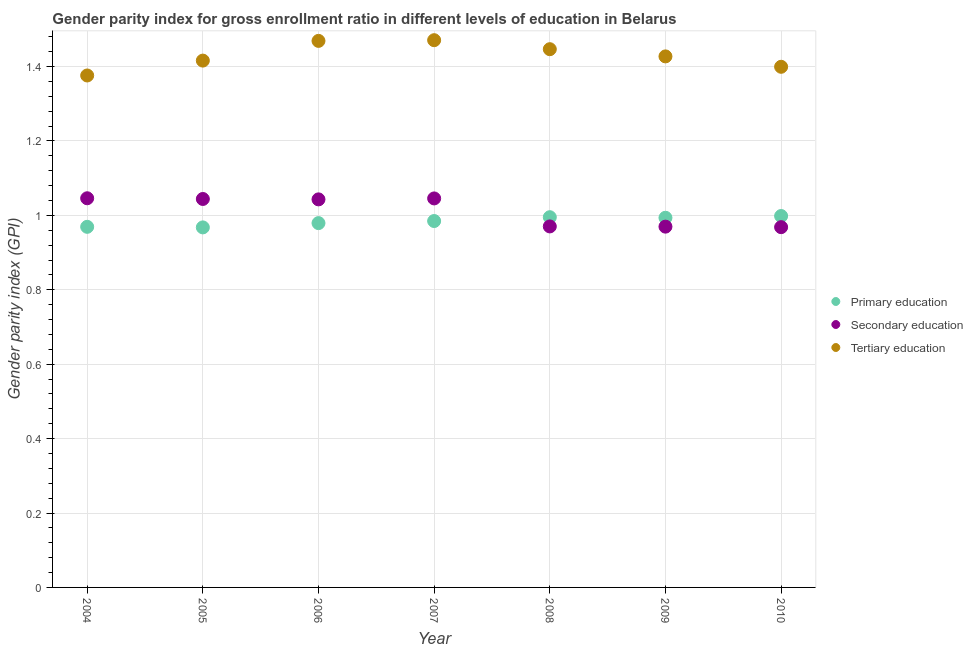How many different coloured dotlines are there?
Offer a very short reply. 3. Is the number of dotlines equal to the number of legend labels?
Provide a succinct answer. Yes. What is the gender parity index in tertiary education in 2004?
Your response must be concise. 1.38. Across all years, what is the maximum gender parity index in primary education?
Your answer should be very brief. 1. Across all years, what is the minimum gender parity index in primary education?
Your answer should be very brief. 0.97. What is the total gender parity index in primary education in the graph?
Your answer should be very brief. 6.89. What is the difference between the gender parity index in secondary education in 2009 and that in 2010?
Your response must be concise. 0. What is the difference between the gender parity index in secondary education in 2010 and the gender parity index in primary education in 2006?
Ensure brevity in your answer.  -0.01. What is the average gender parity index in primary education per year?
Offer a very short reply. 0.98. In the year 2008, what is the difference between the gender parity index in secondary education and gender parity index in primary education?
Provide a succinct answer. -0.02. What is the ratio of the gender parity index in secondary education in 2004 to that in 2009?
Your answer should be very brief. 1.08. What is the difference between the highest and the second highest gender parity index in tertiary education?
Your answer should be very brief. 0. What is the difference between the highest and the lowest gender parity index in primary education?
Your response must be concise. 0.03. Is the gender parity index in secondary education strictly greater than the gender parity index in primary education over the years?
Provide a short and direct response. No. How many years are there in the graph?
Provide a succinct answer. 7. What is the difference between two consecutive major ticks on the Y-axis?
Give a very brief answer. 0.2. Are the values on the major ticks of Y-axis written in scientific E-notation?
Your answer should be compact. No. Does the graph contain grids?
Your answer should be very brief. Yes. Where does the legend appear in the graph?
Keep it short and to the point. Center right. What is the title of the graph?
Ensure brevity in your answer.  Gender parity index for gross enrollment ratio in different levels of education in Belarus. Does "Labor Tax" appear as one of the legend labels in the graph?
Your answer should be compact. No. What is the label or title of the X-axis?
Ensure brevity in your answer.  Year. What is the label or title of the Y-axis?
Offer a very short reply. Gender parity index (GPI). What is the Gender parity index (GPI) in Primary education in 2004?
Your answer should be compact. 0.97. What is the Gender parity index (GPI) of Secondary education in 2004?
Keep it short and to the point. 1.05. What is the Gender parity index (GPI) of Tertiary education in 2004?
Your answer should be compact. 1.38. What is the Gender parity index (GPI) in Primary education in 2005?
Provide a succinct answer. 0.97. What is the Gender parity index (GPI) of Secondary education in 2005?
Keep it short and to the point. 1.04. What is the Gender parity index (GPI) in Tertiary education in 2005?
Your answer should be very brief. 1.42. What is the Gender parity index (GPI) in Primary education in 2006?
Provide a succinct answer. 0.98. What is the Gender parity index (GPI) in Secondary education in 2006?
Give a very brief answer. 1.04. What is the Gender parity index (GPI) in Tertiary education in 2006?
Your response must be concise. 1.47. What is the Gender parity index (GPI) of Primary education in 2007?
Your answer should be very brief. 0.98. What is the Gender parity index (GPI) of Secondary education in 2007?
Offer a terse response. 1.05. What is the Gender parity index (GPI) in Tertiary education in 2007?
Provide a short and direct response. 1.47. What is the Gender parity index (GPI) in Primary education in 2008?
Offer a very short reply. 1. What is the Gender parity index (GPI) in Secondary education in 2008?
Keep it short and to the point. 0.97. What is the Gender parity index (GPI) in Tertiary education in 2008?
Provide a succinct answer. 1.45. What is the Gender parity index (GPI) of Primary education in 2009?
Keep it short and to the point. 0.99. What is the Gender parity index (GPI) of Secondary education in 2009?
Ensure brevity in your answer.  0.97. What is the Gender parity index (GPI) of Tertiary education in 2009?
Give a very brief answer. 1.43. What is the Gender parity index (GPI) of Primary education in 2010?
Your response must be concise. 1. What is the Gender parity index (GPI) of Secondary education in 2010?
Your answer should be very brief. 0.97. What is the Gender parity index (GPI) of Tertiary education in 2010?
Give a very brief answer. 1.4. Across all years, what is the maximum Gender parity index (GPI) of Primary education?
Offer a very short reply. 1. Across all years, what is the maximum Gender parity index (GPI) in Secondary education?
Provide a short and direct response. 1.05. Across all years, what is the maximum Gender parity index (GPI) of Tertiary education?
Your response must be concise. 1.47. Across all years, what is the minimum Gender parity index (GPI) in Primary education?
Your answer should be compact. 0.97. Across all years, what is the minimum Gender parity index (GPI) of Secondary education?
Provide a short and direct response. 0.97. Across all years, what is the minimum Gender parity index (GPI) of Tertiary education?
Offer a terse response. 1.38. What is the total Gender parity index (GPI) in Primary education in the graph?
Offer a terse response. 6.89. What is the total Gender parity index (GPI) of Secondary education in the graph?
Provide a succinct answer. 7.09. What is the total Gender parity index (GPI) in Tertiary education in the graph?
Offer a very short reply. 10.01. What is the difference between the Gender parity index (GPI) of Primary education in 2004 and that in 2005?
Ensure brevity in your answer.  0. What is the difference between the Gender parity index (GPI) of Secondary education in 2004 and that in 2005?
Provide a succinct answer. 0. What is the difference between the Gender parity index (GPI) in Tertiary education in 2004 and that in 2005?
Make the answer very short. -0.04. What is the difference between the Gender parity index (GPI) of Primary education in 2004 and that in 2006?
Provide a succinct answer. -0.01. What is the difference between the Gender parity index (GPI) in Secondary education in 2004 and that in 2006?
Keep it short and to the point. 0. What is the difference between the Gender parity index (GPI) of Tertiary education in 2004 and that in 2006?
Offer a very short reply. -0.09. What is the difference between the Gender parity index (GPI) in Primary education in 2004 and that in 2007?
Offer a terse response. -0.02. What is the difference between the Gender parity index (GPI) in Tertiary education in 2004 and that in 2007?
Your response must be concise. -0.09. What is the difference between the Gender parity index (GPI) in Primary education in 2004 and that in 2008?
Give a very brief answer. -0.03. What is the difference between the Gender parity index (GPI) in Secondary education in 2004 and that in 2008?
Offer a very short reply. 0.08. What is the difference between the Gender parity index (GPI) of Tertiary education in 2004 and that in 2008?
Your answer should be very brief. -0.07. What is the difference between the Gender parity index (GPI) in Primary education in 2004 and that in 2009?
Provide a short and direct response. -0.02. What is the difference between the Gender parity index (GPI) in Secondary education in 2004 and that in 2009?
Offer a very short reply. 0.08. What is the difference between the Gender parity index (GPI) in Tertiary education in 2004 and that in 2009?
Your answer should be very brief. -0.05. What is the difference between the Gender parity index (GPI) of Primary education in 2004 and that in 2010?
Give a very brief answer. -0.03. What is the difference between the Gender parity index (GPI) of Secondary education in 2004 and that in 2010?
Provide a succinct answer. 0.08. What is the difference between the Gender parity index (GPI) in Tertiary education in 2004 and that in 2010?
Provide a succinct answer. -0.02. What is the difference between the Gender parity index (GPI) in Primary education in 2005 and that in 2006?
Provide a succinct answer. -0.01. What is the difference between the Gender parity index (GPI) of Secondary education in 2005 and that in 2006?
Offer a terse response. 0. What is the difference between the Gender parity index (GPI) in Tertiary education in 2005 and that in 2006?
Your response must be concise. -0.05. What is the difference between the Gender parity index (GPI) of Primary education in 2005 and that in 2007?
Your answer should be compact. -0.02. What is the difference between the Gender parity index (GPI) of Secondary education in 2005 and that in 2007?
Ensure brevity in your answer.  -0. What is the difference between the Gender parity index (GPI) in Tertiary education in 2005 and that in 2007?
Provide a succinct answer. -0.05. What is the difference between the Gender parity index (GPI) of Primary education in 2005 and that in 2008?
Offer a terse response. -0.03. What is the difference between the Gender parity index (GPI) in Secondary education in 2005 and that in 2008?
Give a very brief answer. 0.07. What is the difference between the Gender parity index (GPI) in Tertiary education in 2005 and that in 2008?
Your response must be concise. -0.03. What is the difference between the Gender parity index (GPI) of Primary education in 2005 and that in 2009?
Provide a short and direct response. -0.03. What is the difference between the Gender parity index (GPI) of Secondary education in 2005 and that in 2009?
Offer a terse response. 0.07. What is the difference between the Gender parity index (GPI) of Tertiary education in 2005 and that in 2009?
Provide a succinct answer. -0.01. What is the difference between the Gender parity index (GPI) in Primary education in 2005 and that in 2010?
Ensure brevity in your answer.  -0.03. What is the difference between the Gender parity index (GPI) of Secondary education in 2005 and that in 2010?
Provide a succinct answer. 0.08. What is the difference between the Gender parity index (GPI) in Tertiary education in 2005 and that in 2010?
Give a very brief answer. 0.02. What is the difference between the Gender parity index (GPI) in Primary education in 2006 and that in 2007?
Make the answer very short. -0.01. What is the difference between the Gender parity index (GPI) in Secondary education in 2006 and that in 2007?
Provide a short and direct response. -0. What is the difference between the Gender parity index (GPI) in Tertiary education in 2006 and that in 2007?
Provide a short and direct response. -0. What is the difference between the Gender parity index (GPI) in Primary education in 2006 and that in 2008?
Provide a succinct answer. -0.02. What is the difference between the Gender parity index (GPI) in Secondary education in 2006 and that in 2008?
Offer a terse response. 0.07. What is the difference between the Gender parity index (GPI) of Tertiary education in 2006 and that in 2008?
Give a very brief answer. 0.02. What is the difference between the Gender parity index (GPI) in Primary education in 2006 and that in 2009?
Offer a very short reply. -0.01. What is the difference between the Gender parity index (GPI) of Secondary education in 2006 and that in 2009?
Provide a short and direct response. 0.07. What is the difference between the Gender parity index (GPI) in Tertiary education in 2006 and that in 2009?
Offer a very short reply. 0.04. What is the difference between the Gender parity index (GPI) in Primary education in 2006 and that in 2010?
Provide a short and direct response. -0.02. What is the difference between the Gender parity index (GPI) in Secondary education in 2006 and that in 2010?
Offer a terse response. 0.07. What is the difference between the Gender parity index (GPI) in Tertiary education in 2006 and that in 2010?
Make the answer very short. 0.07. What is the difference between the Gender parity index (GPI) of Primary education in 2007 and that in 2008?
Ensure brevity in your answer.  -0.01. What is the difference between the Gender parity index (GPI) of Secondary education in 2007 and that in 2008?
Your answer should be compact. 0.08. What is the difference between the Gender parity index (GPI) in Tertiary education in 2007 and that in 2008?
Offer a terse response. 0.02. What is the difference between the Gender parity index (GPI) in Primary education in 2007 and that in 2009?
Make the answer very short. -0.01. What is the difference between the Gender parity index (GPI) in Secondary education in 2007 and that in 2009?
Your answer should be compact. 0.08. What is the difference between the Gender parity index (GPI) of Tertiary education in 2007 and that in 2009?
Keep it short and to the point. 0.04. What is the difference between the Gender parity index (GPI) in Primary education in 2007 and that in 2010?
Your answer should be very brief. -0.01. What is the difference between the Gender parity index (GPI) in Secondary education in 2007 and that in 2010?
Your answer should be very brief. 0.08. What is the difference between the Gender parity index (GPI) of Tertiary education in 2007 and that in 2010?
Ensure brevity in your answer.  0.07. What is the difference between the Gender parity index (GPI) of Primary education in 2008 and that in 2009?
Make the answer very short. 0. What is the difference between the Gender parity index (GPI) in Secondary education in 2008 and that in 2009?
Give a very brief answer. 0. What is the difference between the Gender parity index (GPI) of Tertiary education in 2008 and that in 2009?
Your answer should be compact. 0.02. What is the difference between the Gender parity index (GPI) of Primary education in 2008 and that in 2010?
Give a very brief answer. -0. What is the difference between the Gender parity index (GPI) in Secondary education in 2008 and that in 2010?
Provide a short and direct response. 0. What is the difference between the Gender parity index (GPI) in Tertiary education in 2008 and that in 2010?
Your response must be concise. 0.05. What is the difference between the Gender parity index (GPI) of Primary education in 2009 and that in 2010?
Provide a short and direct response. -0. What is the difference between the Gender parity index (GPI) of Secondary education in 2009 and that in 2010?
Keep it short and to the point. 0. What is the difference between the Gender parity index (GPI) in Tertiary education in 2009 and that in 2010?
Your response must be concise. 0.03. What is the difference between the Gender parity index (GPI) of Primary education in 2004 and the Gender parity index (GPI) of Secondary education in 2005?
Offer a terse response. -0.07. What is the difference between the Gender parity index (GPI) in Primary education in 2004 and the Gender parity index (GPI) in Tertiary education in 2005?
Your response must be concise. -0.45. What is the difference between the Gender parity index (GPI) in Secondary education in 2004 and the Gender parity index (GPI) in Tertiary education in 2005?
Your response must be concise. -0.37. What is the difference between the Gender parity index (GPI) of Primary education in 2004 and the Gender parity index (GPI) of Secondary education in 2006?
Keep it short and to the point. -0.07. What is the difference between the Gender parity index (GPI) of Primary education in 2004 and the Gender parity index (GPI) of Tertiary education in 2006?
Ensure brevity in your answer.  -0.5. What is the difference between the Gender parity index (GPI) of Secondary education in 2004 and the Gender parity index (GPI) of Tertiary education in 2006?
Give a very brief answer. -0.42. What is the difference between the Gender parity index (GPI) of Primary education in 2004 and the Gender parity index (GPI) of Secondary education in 2007?
Provide a short and direct response. -0.08. What is the difference between the Gender parity index (GPI) of Primary education in 2004 and the Gender parity index (GPI) of Tertiary education in 2007?
Ensure brevity in your answer.  -0.5. What is the difference between the Gender parity index (GPI) of Secondary education in 2004 and the Gender parity index (GPI) of Tertiary education in 2007?
Provide a short and direct response. -0.42. What is the difference between the Gender parity index (GPI) in Primary education in 2004 and the Gender parity index (GPI) in Secondary education in 2008?
Ensure brevity in your answer.  -0. What is the difference between the Gender parity index (GPI) in Primary education in 2004 and the Gender parity index (GPI) in Tertiary education in 2008?
Provide a short and direct response. -0.48. What is the difference between the Gender parity index (GPI) of Secondary education in 2004 and the Gender parity index (GPI) of Tertiary education in 2008?
Offer a very short reply. -0.4. What is the difference between the Gender parity index (GPI) in Primary education in 2004 and the Gender parity index (GPI) in Secondary education in 2009?
Ensure brevity in your answer.  -0. What is the difference between the Gender parity index (GPI) in Primary education in 2004 and the Gender parity index (GPI) in Tertiary education in 2009?
Provide a short and direct response. -0.46. What is the difference between the Gender parity index (GPI) in Secondary education in 2004 and the Gender parity index (GPI) in Tertiary education in 2009?
Offer a terse response. -0.38. What is the difference between the Gender parity index (GPI) in Primary education in 2004 and the Gender parity index (GPI) in Secondary education in 2010?
Offer a very short reply. 0. What is the difference between the Gender parity index (GPI) of Primary education in 2004 and the Gender parity index (GPI) of Tertiary education in 2010?
Offer a terse response. -0.43. What is the difference between the Gender parity index (GPI) in Secondary education in 2004 and the Gender parity index (GPI) in Tertiary education in 2010?
Provide a short and direct response. -0.35. What is the difference between the Gender parity index (GPI) in Primary education in 2005 and the Gender parity index (GPI) in Secondary education in 2006?
Ensure brevity in your answer.  -0.08. What is the difference between the Gender parity index (GPI) in Primary education in 2005 and the Gender parity index (GPI) in Tertiary education in 2006?
Give a very brief answer. -0.5. What is the difference between the Gender parity index (GPI) in Secondary education in 2005 and the Gender parity index (GPI) in Tertiary education in 2006?
Provide a succinct answer. -0.42. What is the difference between the Gender parity index (GPI) of Primary education in 2005 and the Gender parity index (GPI) of Secondary education in 2007?
Offer a terse response. -0.08. What is the difference between the Gender parity index (GPI) of Primary education in 2005 and the Gender parity index (GPI) of Tertiary education in 2007?
Your response must be concise. -0.5. What is the difference between the Gender parity index (GPI) of Secondary education in 2005 and the Gender parity index (GPI) of Tertiary education in 2007?
Provide a short and direct response. -0.43. What is the difference between the Gender parity index (GPI) of Primary education in 2005 and the Gender parity index (GPI) of Secondary education in 2008?
Your answer should be very brief. -0. What is the difference between the Gender parity index (GPI) in Primary education in 2005 and the Gender parity index (GPI) in Tertiary education in 2008?
Give a very brief answer. -0.48. What is the difference between the Gender parity index (GPI) in Secondary education in 2005 and the Gender parity index (GPI) in Tertiary education in 2008?
Offer a very short reply. -0.4. What is the difference between the Gender parity index (GPI) of Primary education in 2005 and the Gender parity index (GPI) of Secondary education in 2009?
Ensure brevity in your answer.  -0. What is the difference between the Gender parity index (GPI) of Primary education in 2005 and the Gender parity index (GPI) of Tertiary education in 2009?
Ensure brevity in your answer.  -0.46. What is the difference between the Gender parity index (GPI) of Secondary education in 2005 and the Gender parity index (GPI) of Tertiary education in 2009?
Offer a terse response. -0.38. What is the difference between the Gender parity index (GPI) in Primary education in 2005 and the Gender parity index (GPI) in Secondary education in 2010?
Provide a short and direct response. -0. What is the difference between the Gender parity index (GPI) in Primary education in 2005 and the Gender parity index (GPI) in Tertiary education in 2010?
Ensure brevity in your answer.  -0.43. What is the difference between the Gender parity index (GPI) of Secondary education in 2005 and the Gender parity index (GPI) of Tertiary education in 2010?
Keep it short and to the point. -0.36. What is the difference between the Gender parity index (GPI) in Primary education in 2006 and the Gender parity index (GPI) in Secondary education in 2007?
Keep it short and to the point. -0.07. What is the difference between the Gender parity index (GPI) in Primary education in 2006 and the Gender parity index (GPI) in Tertiary education in 2007?
Make the answer very short. -0.49. What is the difference between the Gender parity index (GPI) in Secondary education in 2006 and the Gender parity index (GPI) in Tertiary education in 2007?
Your answer should be very brief. -0.43. What is the difference between the Gender parity index (GPI) of Primary education in 2006 and the Gender parity index (GPI) of Secondary education in 2008?
Offer a terse response. 0.01. What is the difference between the Gender parity index (GPI) of Primary education in 2006 and the Gender parity index (GPI) of Tertiary education in 2008?
Ensure brevity in your answer.  -0.47. What is the difference between the Gender parity index (GPI) of Secondary education in 2006 and the Gender parity index (GPI) of Tertiary education in 2008?
Make the answer very short. -0.4. What is the difference between the Gender parity index (GPI) of Primary education in 2006 and the Gender parity index (GPI) of Secondary education in 2009?
Offer a very short reply. 0.01. What is the difference between the Gender parity index (GPI) in Primary education in 2006 and the Gender parity index (GPI) in Tertiary education in 2009?
Give a very brief answer. -0.45. What is the difference between the Gender parity index (GPI) in Secondary education in 2006 and the Gender parity index (GPI) in Tertiary education in 2009?
Your answer should be very brief. -0.38. What is the difference between the Gender parity index (GPI) of Primary education in 2006 and the Gender parity index (GPI) of Secondary education in 2010?
Your answer should be compact. 0.01. What is the difference between the Gender parity index (GPI) in Primary education in 2006 and the Gender parity index (GPI) in Tertiary education in 2010?
Your answer should be compact. -0.42. What is the difference between the Gender parity index (GPI) of Secondary education in 2006 and the Gender parity index (GPI) of Tertiary education in 2010?
Your answer should be compact. -0.36. What is the difference between the Gender parity index (GPI) of Primary education in 2007 and the Gender parity index (GPI) of Secondary education in 2008?
Ensure brevity in your answer.  0.01. What is the difference between the Gender parity index (GPI) of Primary education in 2007 and the Gender parity index (GPI) of Tertiary education in 2008?
Your response must be concise. -0.46. What is the difference between the Gender parity index (GPI) of Secondary education in 2007 and the Gender parity index (GPI) of Tertiary education in 2008?
Make the answer very short. -0.4. What is the difference between the Gender parity index (GPI) in Primary education in 2007 and the Gender parity index (GPI) in Secondary education in 2009?
Keep it short and to the point. 0.02. What is the difference between the Gender parity index (GPI) of Primary education in 2007 and the Gender parity index (GPI) of Tertiary education in 2009?
Offer a very short reply. -0.44. What is the difference between the Gender parity index (GPI) of Secondary education in 2007 and the Gender parity index (GPI) of Tertiary education in 2009?
Your answer should be compact. -0.38. What is the difference between the Gender parity index (GPI) in Primary education in 2007 and the Gender parity index (GPI) in Secondary education in 2010?
Ensure brevity in your answer.  0.02. What is the difference between the Gender parity index (GPI) of Primary education in 2007 and the Gender parity index (GPI) of Tertiary education in 2010?
Your response must be concise. -0.41. What is the difference between the Gender parity index (GPI) of Secondary education in 2007 and the Gender parity index (GPI) of Tertiary education in 2010?
Give a very brief answer. -0.35. What is the difference between the Gender parity index (GPI) in Primary education in 2008 and the Gender parity index (GPI) in Secondary education in 2009?
Your response must be concise. 0.03. What is the difference between the Gender parity index (GPI) of Primary education in 2008 and the Gender parity index (GPI) of Tertiary education in 2009?
Give a very brief answer. -0.43. What is the difference between the Gender parity index (GPI) of Secondary education in 2008 and the Gender parity index (GPI) of Tertiary education in 2009?
Your response must be concise. -0.46. What is the difference between the Gender parity index (GPI) of Primary education in 2008 and the Gender parity index (GPI) of Secondary education in 2010?
Offer a terse response. 0.03. What is the difference between the Gender parity index (GPI) of Primary education in 2008 and the Gender parity index (GPI) of Tertiary education in 2010?
Make the answer very short. -0.4. What is the difference between the Gender parity index (GPI) of Secondary education in 2008 and the Gender parity index (GPI) of Tertiary education in 2010?
Offer a very short reply. -0.43. What is the difference between the Gender parity index (GPI) in Primary education in 2009 and the Gender parity index (GPI) in Secondary education in 2010?
Offer a very short reply. 0.03. What is the difference between the Gender parity index (GPI) in Primary education in 2009 and the Gender parity index (GPI) in Tertiary education in 2010?
Provide a short and direct response. -0.41. What is the difference between the Gender parity index (GPI) of Secondary education in 2009 and the Gender parity index (GPI) of Tertiary education in 2010?
Ensure brevity in your answer.  -0.43. What is the average Gender parity index (GPI) of Primary education per year?
Ensure brevity in your answer.  0.98. What is the average Gender parity index (GPI) in Secondary education per year?
Offer a terse response. 1.01. What is the average Gender parity index (GPI) in Tertiary education per year?
Your answer should be very brief. 1.43. In the year 2004, what is the difference between the Gender parity index (GPI) of Primary education and Gender parity index (GPI) of Secondary education?
Your answer should be compact. -0.08. In the year 2004, what is the difference between the Gender parity index (GPI) of Primary education and Gender parity index (GPI) of Tertiary education?
Offer a very short reply. -0.41. In the year 2004, what is the difference between the Gender parity index (GPI) in Secondary education and Gender parity index (GPI) in Tertiary education?
Your answer should be compact. -0.33. In the year 2005, what is the difference between the Gender parity index (GPI) of Primary education and Gender parity index (GPI) of Secondary education?
Provide a short and direct response. -0.08. In the year 2005, what is the difference between the Gender parity index (GPI) in Primary education and Gender parity index (GPI) in Tertiary education?
Make the answer very short. -0.45. In the year 2005, what is the difference between the Gender parity index (GPI) of Secondary education and Gender parity index (GPI) of Tertiary education?
Ensure brevity in your answer.  -0.37. In the year 2006, what is the difference between the Gender parity index (GPI) of Primary education and Gender parity index (GPI) of Secondary education?
Keep it short and to the point. -0.06. In the year 2006, what is the difference between the Gender parity index (GPI) in Primary education and Gender parity index (GPI) in Tertiary education?
Offer a terse response. -0.49. In the year 2006, what is the difference between the Gender parity index (GPI) of Secondary education and Gender parity index (GPI) of Tertiary education?
Your answer should be very brief. -0.43. In the year 2007, what is the difference between the Gender parity index (GPI) in Primary education and Gender parity index (GPI) in Secondary education?
Make the answer very short. -0.06. In the year 2007, what is the difference between the Gender parity index (GPI) in Primary education and Gender parity index (GPI) in Tertiary education?
Your answer should be compact. -0.49. In the year 2007, what is the difference between the Gender parity index (GPI) of Secondary education and Gender parity index (GPI) of Tertiary education?
Your answer should be compact. -0.43. In the year 2008, what is the difference between the Gender parity index (GPI) of Primary education and Gender parity index (GPI) of Secondary education?
Keep it short and to the point. 0.02. In the year 2008, what is the difference between the Gender parity index (GPI) of Primary education and Gender parity index (GPI) of Tertiary education?
Keep it short and to the point. -0.45. In the year 2008, what is the difference between the Gender parity index (GPI) in Secondary education and Gender parity index (GPI) in Tertiary education?
Ensure brevity in your answer.  -0.48. In the year 2009, what is the difference between the Gender parity index (GPI) in Primary education and Gender parity index (GPI) in Secondary education?
Offer a very short reply. 0.02. In the year 2009, what is the difference between the Gender parity index (GPI) in Primary education and Gender parity index (GPI) in Tertiary education?
Offer a very short reply. -0.43. In the year 2009, what is the difference between the Gender parity index (GPI) in Secondary education and Gender parity index (GPI) in Tertiary education?
Give a very brief answer. -0.46. In the year 2010, what is the difference between the Gender parity index (GPI) in Primary education and Gender parity index (GPI) in Secondary education?
Keep it short and to the point. 0.03. In the year 2010, what is the difference between the Gender parity index (GPI) in Primary education and Gender parity index (GPI) in Tertiary education?
Offer a terse response. -0.4. In the year 2010, what is the difference between the Gender parity index (GPI) in Secondary education and Gender parity index (GPI) in Tertiary education?
Ensure brevity in your answer.  -0.43. What is the ratio of the Gender parity index (GPI) of Tertiary education in 2004 to that in 2005?
Provide a short and direct response. 0.97. What is the ratio of the Gender parity index (GPI) in Primary education in 2004 to that in 2006?
Your response must be concise. 0.99. What is the ratio of the Gender parity index (GPI) in Tertiary education in 2004 to that in 2006?
Your answer should be very brief. 0.94. What is the ratio of the Gender parity index (GPI) of Primary education in 2004 to that in 2007?
Offer a terse response. 0.98. What is the ratio of the Gender parity index (GPI) in Secondary education in 2004 to that in 2007?
Keep it short and to the point. 1. What is the ratio of the Gender parity index (GPI) of Tertiary education in 2004 to that in 2007?
Make the answer very short. 0.94. What is the ratio of the Gender parity index (GPI) of Secondary education in 2004 to that in 2008?
Offer a terse response. 1.08. What is the ratio of the Gender parity index (GPI) of Tertiary education in 2004 to that in 2008?
Your answer should be compact. 0.95. What is the ratio of the Gender parity index (GPI) of Primary education in 2004 to that in 2009?
Make the answer very short. 0.98. What is the ratio of the Gender parity index (GPI) in Secondary education in 2004 to that in 2009?
Your answer should be compact. 1.08. What is the ratio of the Gender parity index (GPI) of Tertiary education in 2004 to that in 2009?
Your answer should be very brief. 0.96. What is the ratio of the Gender parity index (GPI) in Primary education in 2004 to that in 2010?
Give a very brief answer. 0.97. What is the ratio of the Gender parity index (GPI) of Secondary education in 2004 to that in 2010?
Offer a very short reply. 1.08. What is the ratio of the Gender parity index (GPI) of Tertiary education in 2004 to that in 2010?
Ensure brevity in your answer.  0.98. What is the ratio of the Gender parity index (GPI) in Primary education in 2005 to that in 2006?
Make the answer very short. 0.99. What is the ratio of the Gender parity index (GPI) of Tertiary education in 2005 to that in 2006?
Keep it short and to the point. 0.96. What is the ratio of the Gender parity index (GPI) of Primary education in 2005 to that in 2007?
Make the answer very short. 0.98. What is the ratio of the Gender parity index (GPI) in Tertiary education in 2005 to that in 2007?
Offer a very short reply. 0.96. What is the ratio of the Gender parity index (GPI) of Primary education in 2005 to that in 2008?
Offer a terse response. 0.97. What is the ratio of the Gender parity index (GPI) in Secondary education in 2005 to that in 2008?
Your answer should be very brief. 1.08. What is the ratio of the Gender parity index (GPI) in Tertiary education in 2005 to that in 2008?
Keep it short and to the point. 0.98. What is the ratio of the Gender parity index (GPI) of Primary education in 2005 to that in 2009?
Give a very brief answer. 0.97. What is the ratio of the Gender parity index (GPI) in Secondary education in 2005 to that in 2009?
Keep it short and to the point. 1.08. What is the ratio of the Gender parity index (GPI) of Tertiary education in 2005 to that in 2009?
Your answer should be compact. 0.99. What is the ratio of the Gender parity index (GPI) in Primary education in 2005 to that in 2010?
Make the answer very short. 0.97. What is the ratio of the Gender parity index (GPI) of Secondary education in 2005 to that in 2010?
Provide a short and direct response. 1.08. What is the ratio of the Gender parity index (GPI) in Tertiary education in 2005 to that in 2010?
Your answer should be compact. 1.01. What is the ratio of the Gender parity index (GPI) in Tertiary education in 2006 to that in 2007?
Offer a terse response. 1. What is the ratio of the Gender parity index (GPI) in Primary education in 2006 to that in 2008?
Provide a short and direct response. 0.98. What is the ratio of the Gender parity index (GPI) of Secondary education in 2006 to that in 2008?
Make the answer very short. 1.07. What is the ratio of the Gender parity index (GPI) in Tertiary education in 2006 to that in 2008?
Provide a succinct answer. 1.02. What is the ratio of the Gender parity index (GPI) of Primary education in 2006 to that in 2009?
Your response must be concise. 0.99. What is the ratio of the Gender parity index (GPI) in Secondary education in 2006 to that in 2009?
Provide a succinct answer. 1.08. What is the ratio of the Gender parity index (GPI) of Tertiary education in 2006 to that in 2009?
Your answer should be compact. 1.03. What is the ratio of the Gender parity index (GPI) of Secondary education in 2006 to that in 2010?
Provide a succinct answer. 1.08. What is the ratio of the Gender parity index (GPI) of Tertiary education in 2006 to that in 2010?
Offer a terse response. 1.05. What is the ratio of the Gender parity index (GPI) of Secondary education in 2007 to that in 2008?
Keep it short and to the point. 1.08. What is the ratio of the Gender parity index (GPI) in Tertiary education in 2007 to that in 2008?
Provide a succinct answer. 1.02. What is the ratio of the Gender parity index (GPI) of Secondary education in 2007 to that in 2009?
Ensure brevity in your answer.  1.08. What is the ratio of the Gender parity index (GPI) in Tertiary education in 2007 to that in 2009?
Your answer should be very brief. 1.03. What is the ratio of the Gender parity index (GPI) in Primary education in 2007 to that in 2010?
Ensure brevity in your answer.  0.99. What is the ratio of the Gender parity index (GPI) of Secondary education in 2007 to that in 2010?
Your response must be concise. 1.08. What is the ratio of the Gender parity index (GPI) in Tertiary education in 2007 to that in 2010?
Your response must be concise. 1.05. What is the ratio of the Gender parity index (GPI) in Primary education in 2008 to that in 2009?
Make the answer very short. 1. What is the ratio of the Gender parity index (GPI) of Secondary education in 2008 to that in 2009?
Make the answer very short. 1. What is the ratio of the Gender parity index (GPI) of Tertiary education in 2008 to that in 2009?
Make the answer very short. 1.01. What is the ratio of the Gender parity index (GPI) in Primary education in 2008 to that in 2010?
Offer a terse response. 1. What is the ratio of the Gender parity index (GPI) in Tertiary education in 2008 to that in 2010?
Your response must be concise. 1.03. What is the ratio of the Gender parity index (GPI) in Primary education in 2009 to that in 2010?
Provide a succinct answer. 1. What is the ratio of the Gender parity index (GPI) of Tertiary education in 2009 to that in 2010?
Your answer should be compact. 1.02. What is the difference between the highest and the second highest Gender parity index (GPI) of Primary education?
Ensure brevity in your answer.  0. What is the difference between the highest and the second highest Gender parity index (GPI) of Tertiary education?
Offer a terse response. 0. What is the difference between the highest and the lowest Gender parity index (GPI) of Primary education?
Your answer should be compact. 0.03. What is the difference between the highest and the lowest Gender parity index (GPI) of Secondary education?
Make the answer very short. 0.08. What is the difference between the highest and the lowest Gender parity index (GPI) of Tertiary education?
Give a very brief answer. 0.09. 